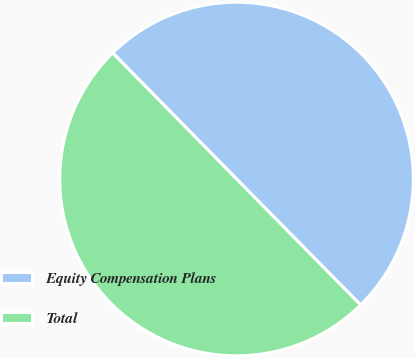<chart> <loc_0><loc_0><loc_500><loc_500><pie_chart><fcel>Equity Compensation Plans<fcel>Total<nl><fcel>49.98%<fcel>50.02%<nl></chart> 